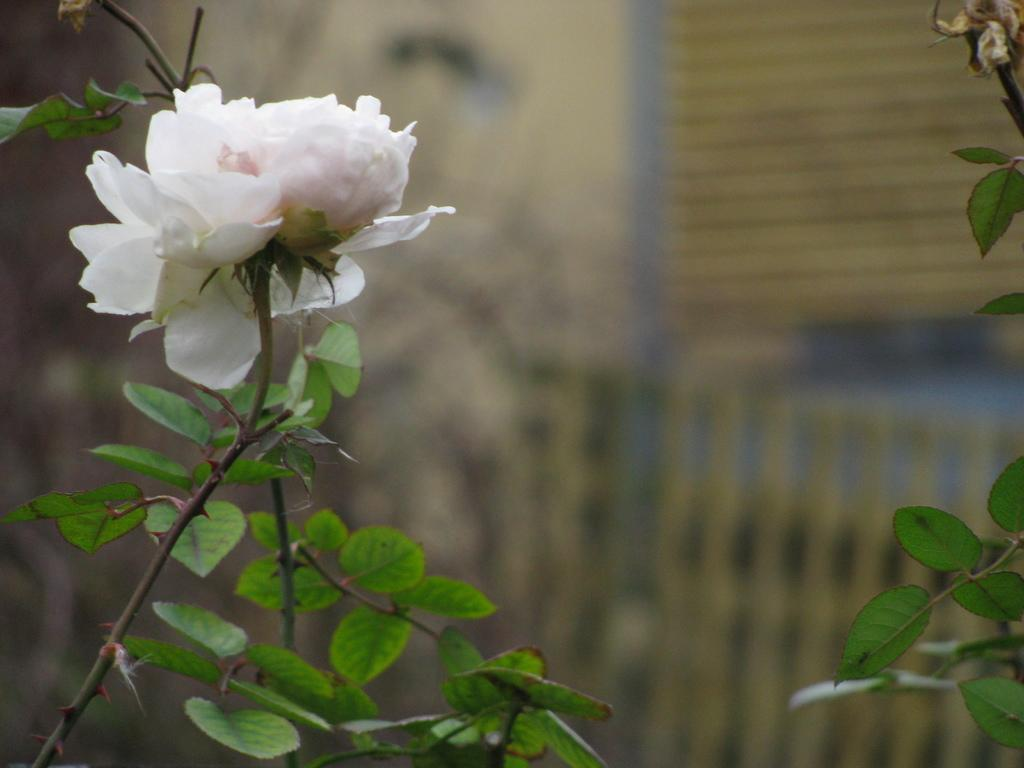What is the main subject of the image? There is a flower in the image. Where is the flower located in the image? The flower is in the center of the image. Can you describe the background of the image? The background of the image is blurry. What type of meat can be seen hanging from the stage in the image? There is no stage or meat present in the image; it features a flower in the center with a blurry background. 